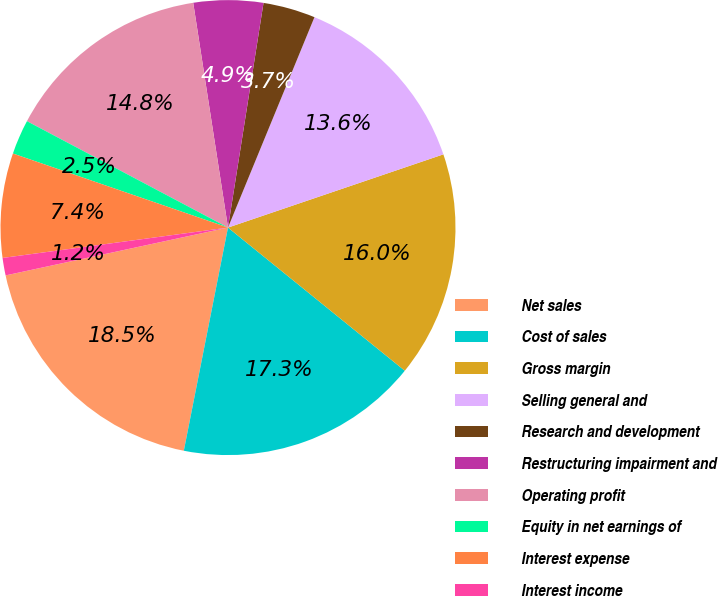<chart> <loc_0><loc_0><loc_500><loc_500><pie_chart><fcel>Net sales<fcel>Cost of sales<fcel>Gross margin<fcel>Selling general and<fcel>Research and development<fcel>Restructuring impairment and<fcel>Operating profit<fcel>Equity in net earnings of<fcel>Interest expense<fcel>Interest income<nl><fcel>18.52%<fcel>17.28%<fcel>16.05%<fcel>13.58%<fcel>3.71%<fcel>4.94%<fcel>14.81%<fcel>2.47%<fcel>7.41%<fcel>1.24%<nl></chart> 